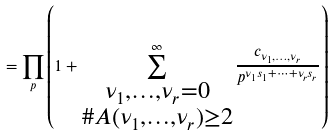Convert formula to latex. <formula><loc_0><loc_0><loc_500><loc_500>= \prod _ { p } \left ( 1 + \sum _ { \substack { \nu _ { 1 } , \dots , \nu _ { r } = 0 \\ \# A ( \nu _ { 1 } , \dots , \nu _ { r } ) \geq 2 } } ^ { \infty } \frac { c _ { \nu _ { 1 } , \dots , \nu _ { r } } } { p ^ { \nu _ { 1 } s _ { 1 } + \cdots + \nu _ { r } s _ { r } } } \right )</formula> 